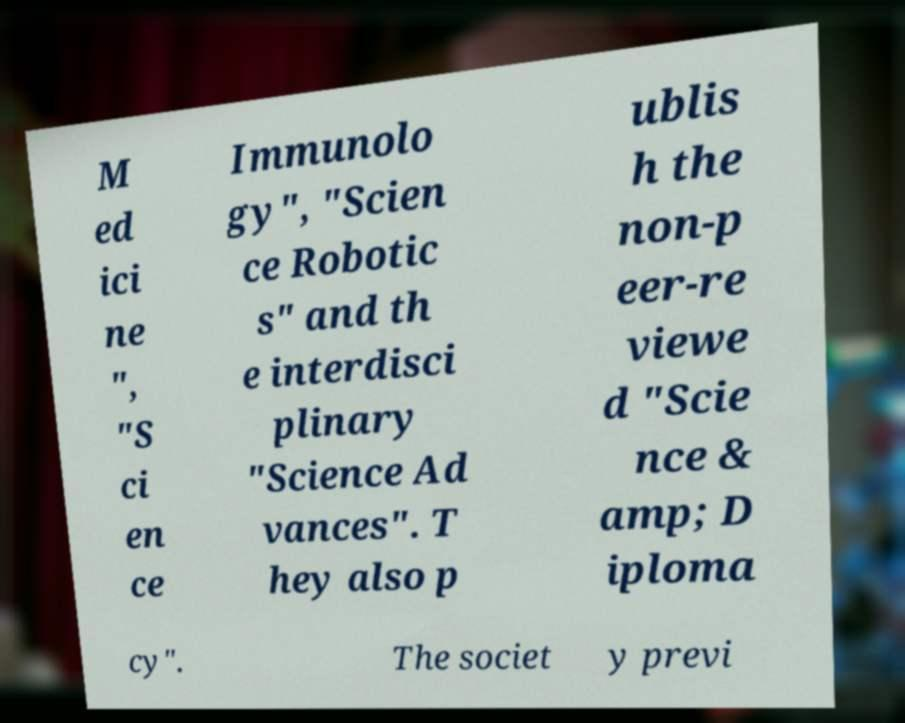What messages or text are displayed in this image? I need them in a readable, typed format. M ed ici ne ", "S ci en ce Immunolo gy", "Scien ce Robotic s" and th e interdisci plinary "Science Ad vances". T hey also p ublis h the non-p eer-re viewe d "Scie nce & amp; D iploma cy". The societ y previ 